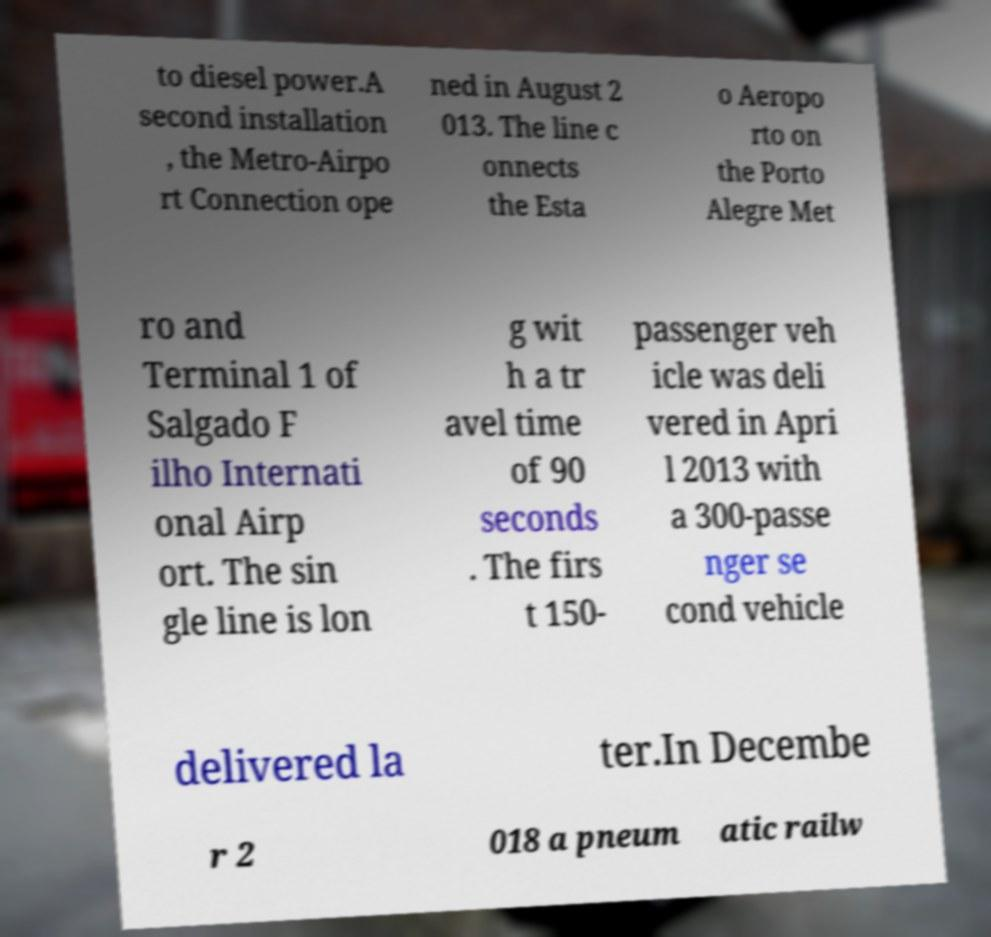Can you accurately transcribe the text from the provided image for me? to diesel power.A second installation , the Metro-Airpo rt Connection ope ned in August 2 013. The line c onnects the Esta o Aeropo rto on the Porto Alegre Met ro and Terminal 1 of Salgado F ilho Internati onal Airp ort. The sin gle line is lon g wit h a tr avel time of 90 seconds . The firs t 150- passenger veh icle was deli vered in Apri l 2013 with a 300-passe nger se cond vehicle delivered la ter.In Decembe r 2 018 a pneum atic railw 